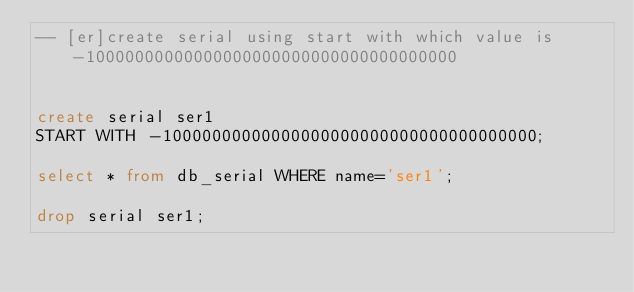Convert code to text. <code><loc_0><loc_0><loc_500><loc_500><_SQL_>-- [er]create serial using start with which value is -10000000000000000000000000000000000000


create serial ser1
START WITH -10000000000000000000000000000000000000;

select * from db_serial WHERE name='ser1';

drop serial ser1;</code> 